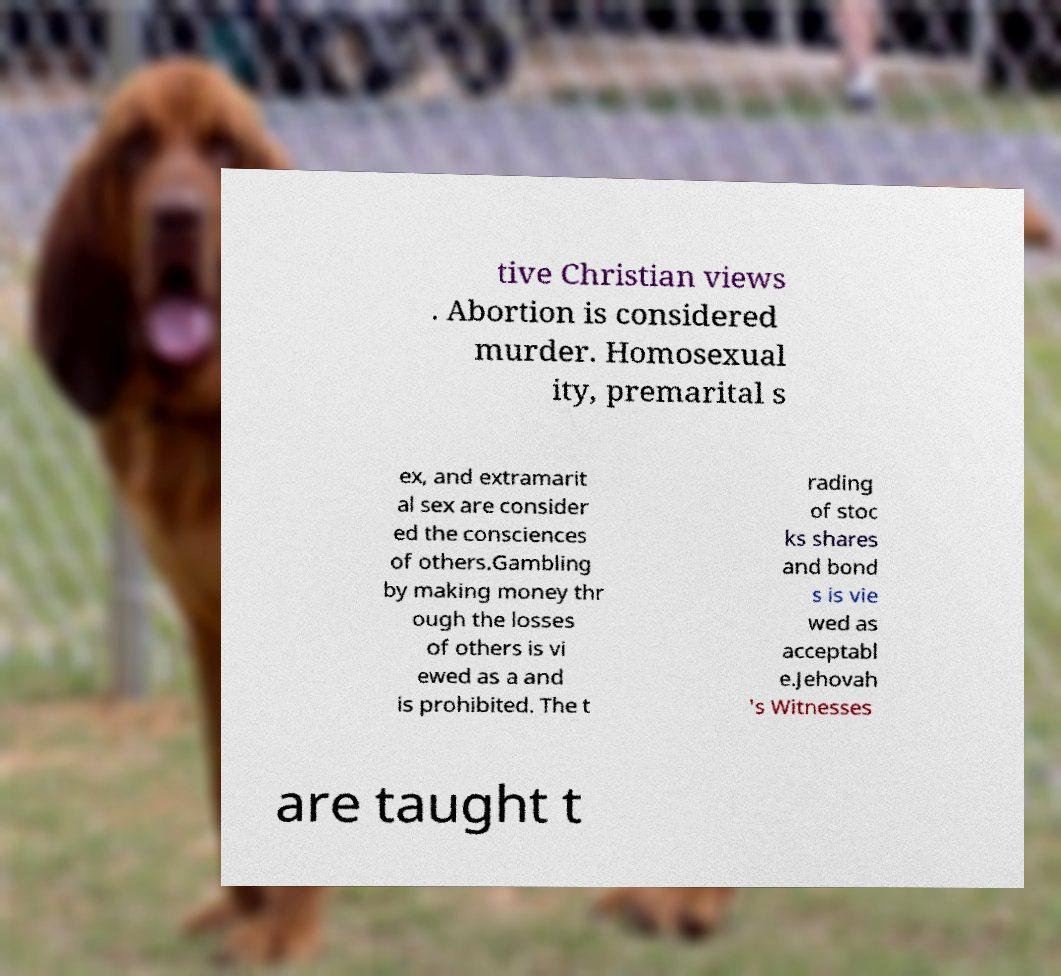Can you accurately transcribe the text from the provided image for me? tive Christian views . Abortion is considered murder. Homosexual ity, premarital s ex, and extramarit al sex are consider ed the consciences of others.Gambling by making money thr ough the losses of others is vi ewed as a and is prohibited. The t rading of stoc ks shares and bond s is vie wed as acceptabl e.Jehovah 's Witnesses are taught t 